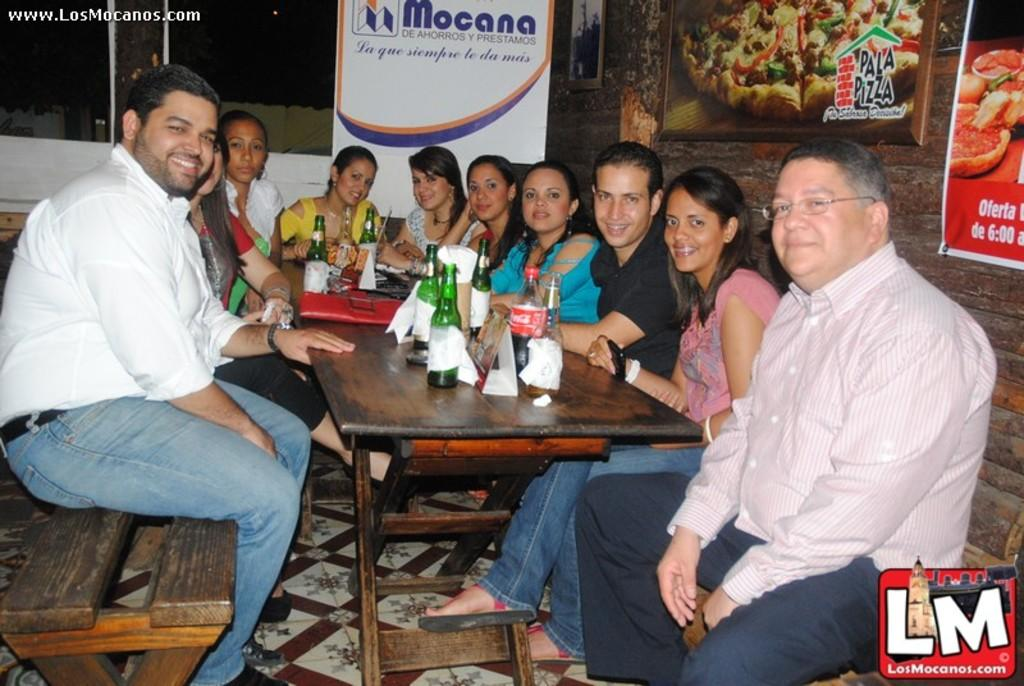What are the people in the image doing? The people in the image are sitting. What objects can be seen on the table in the image? There are bottles and napkins on the table in the image. Can you describe the expressions of the people in the image? Some people in the image are smiling. How many frogs are sitting on the table in the image? There are no frogs present in the image. What statement can be made about the use of the bottles in the image? The use of the bottles cannot be determined from the image alone, as their purpose is not clear. 